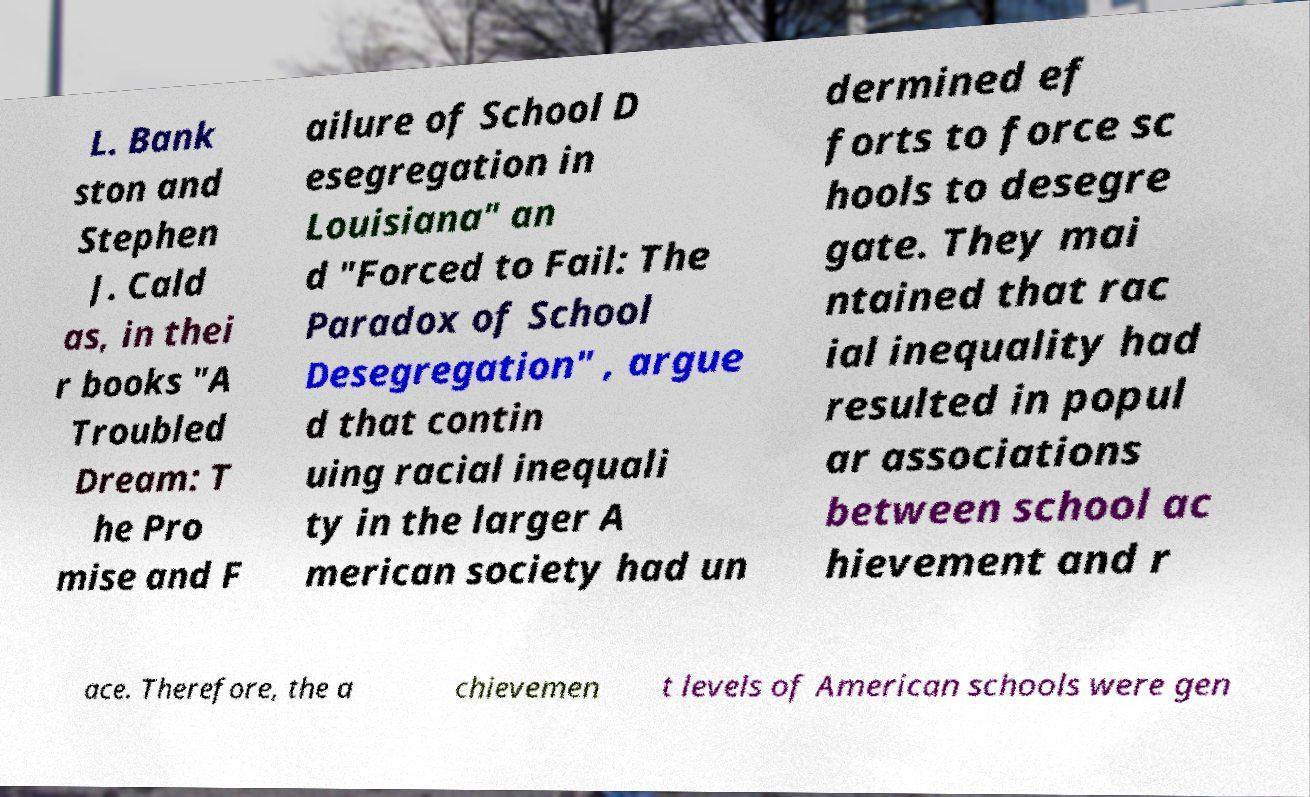Could you assist in decoding the text presented in this image and type it out clearly? L. Bank ston and Stephen J. Cald as, in thei r books "A Troubled Dream: T he Pro mise and F ailure of School D esegregation in Louisiana" an d "Forced to Fail: The Paradox of School Desegregation" , argue d that contin uing racial inequali ty in the larger A merican society had un dermined ef forts to force sc hools to desegre gate. They mai ntained that rac ial inequality had resulted in popul ar associations between school ac hievement and r ace. Therefore, the a chievemen t levels of American schools were gen 